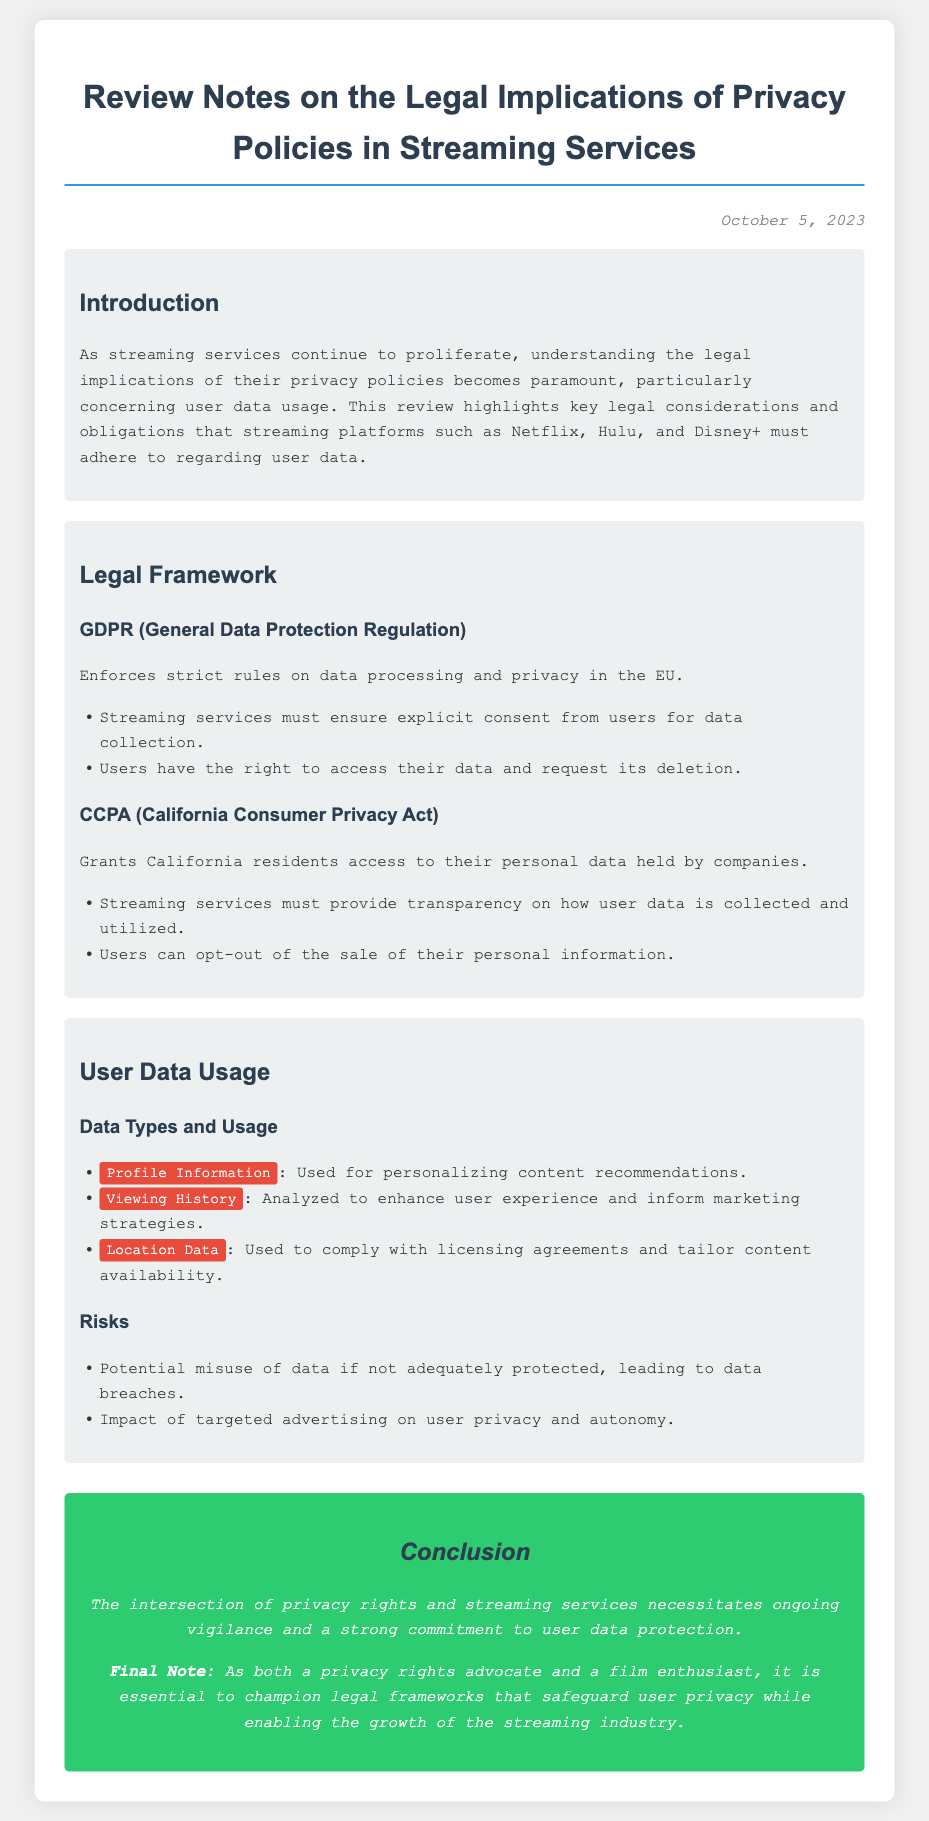What is the date of the document? The date of the document is mentioned in the header as October 5, 2023.
Answer: October 5, 2023 What does GDPR stand for? GDPR is defined in the document as General Data Protection Regulation.
Answer: General Data Protection Regulation Which streaming service is mentioned first in the review? The document highlights Netflix as the first streaming platform in the introduction.
Answer: Netflix What type of data is used for personalizing content recommendations? The document specifies that Profile Information is used for personalizing content recommendations.
Answer: Profile Information What right do users have under GDPR regarding their data? The document states that users have the right to access their data and request its deletion under GDPR.
Answer: Access and deletion What are users able to do under the CCPA? The document indicates users can opt-out of the sale of their personal information under the CCPA.
Answer: Opt-out What is a potential risk associated with user data? The document lists that a potential risk is the misuse of data if not adequately protected, leading to data breaches.
Answer: Data breaches What is the primary focus of the conclusion section? The conclusion stresses the importance of ongoing vigilance and commitment to user data protection.
Answer: User data protection 